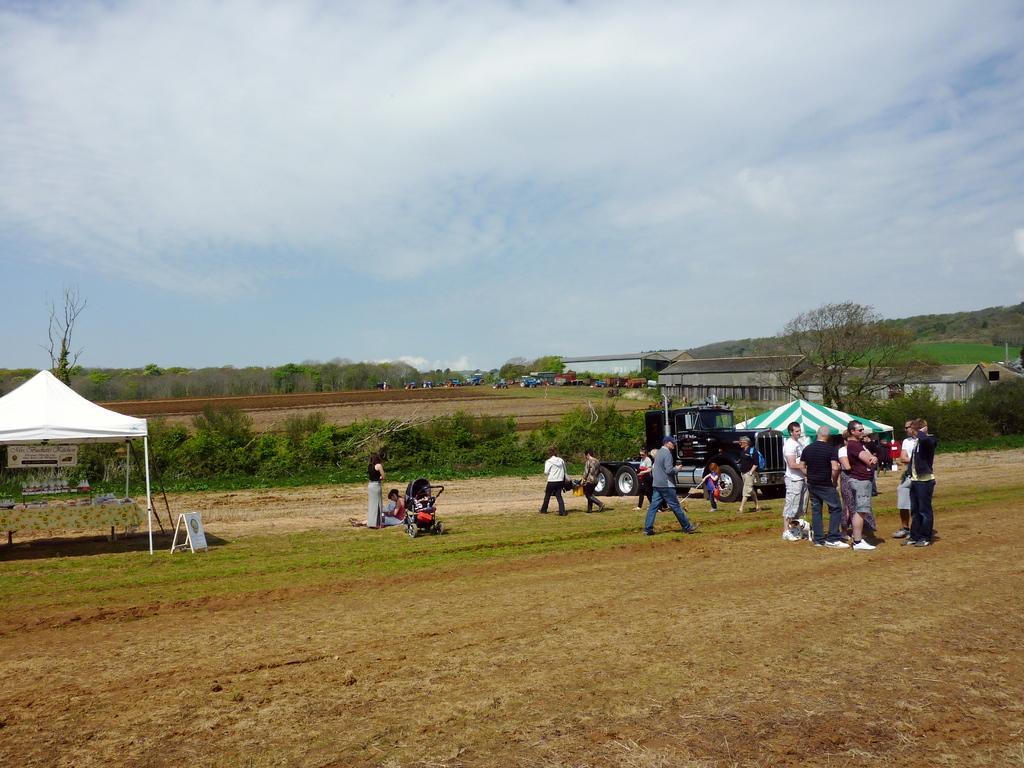Describe this image in one or two sentences. There are people and we can see vehicle on the surface, tents, grass, stroller, board with stand, board and plants. In the background we can see sheds, vehicles, grass, trees and sky. 